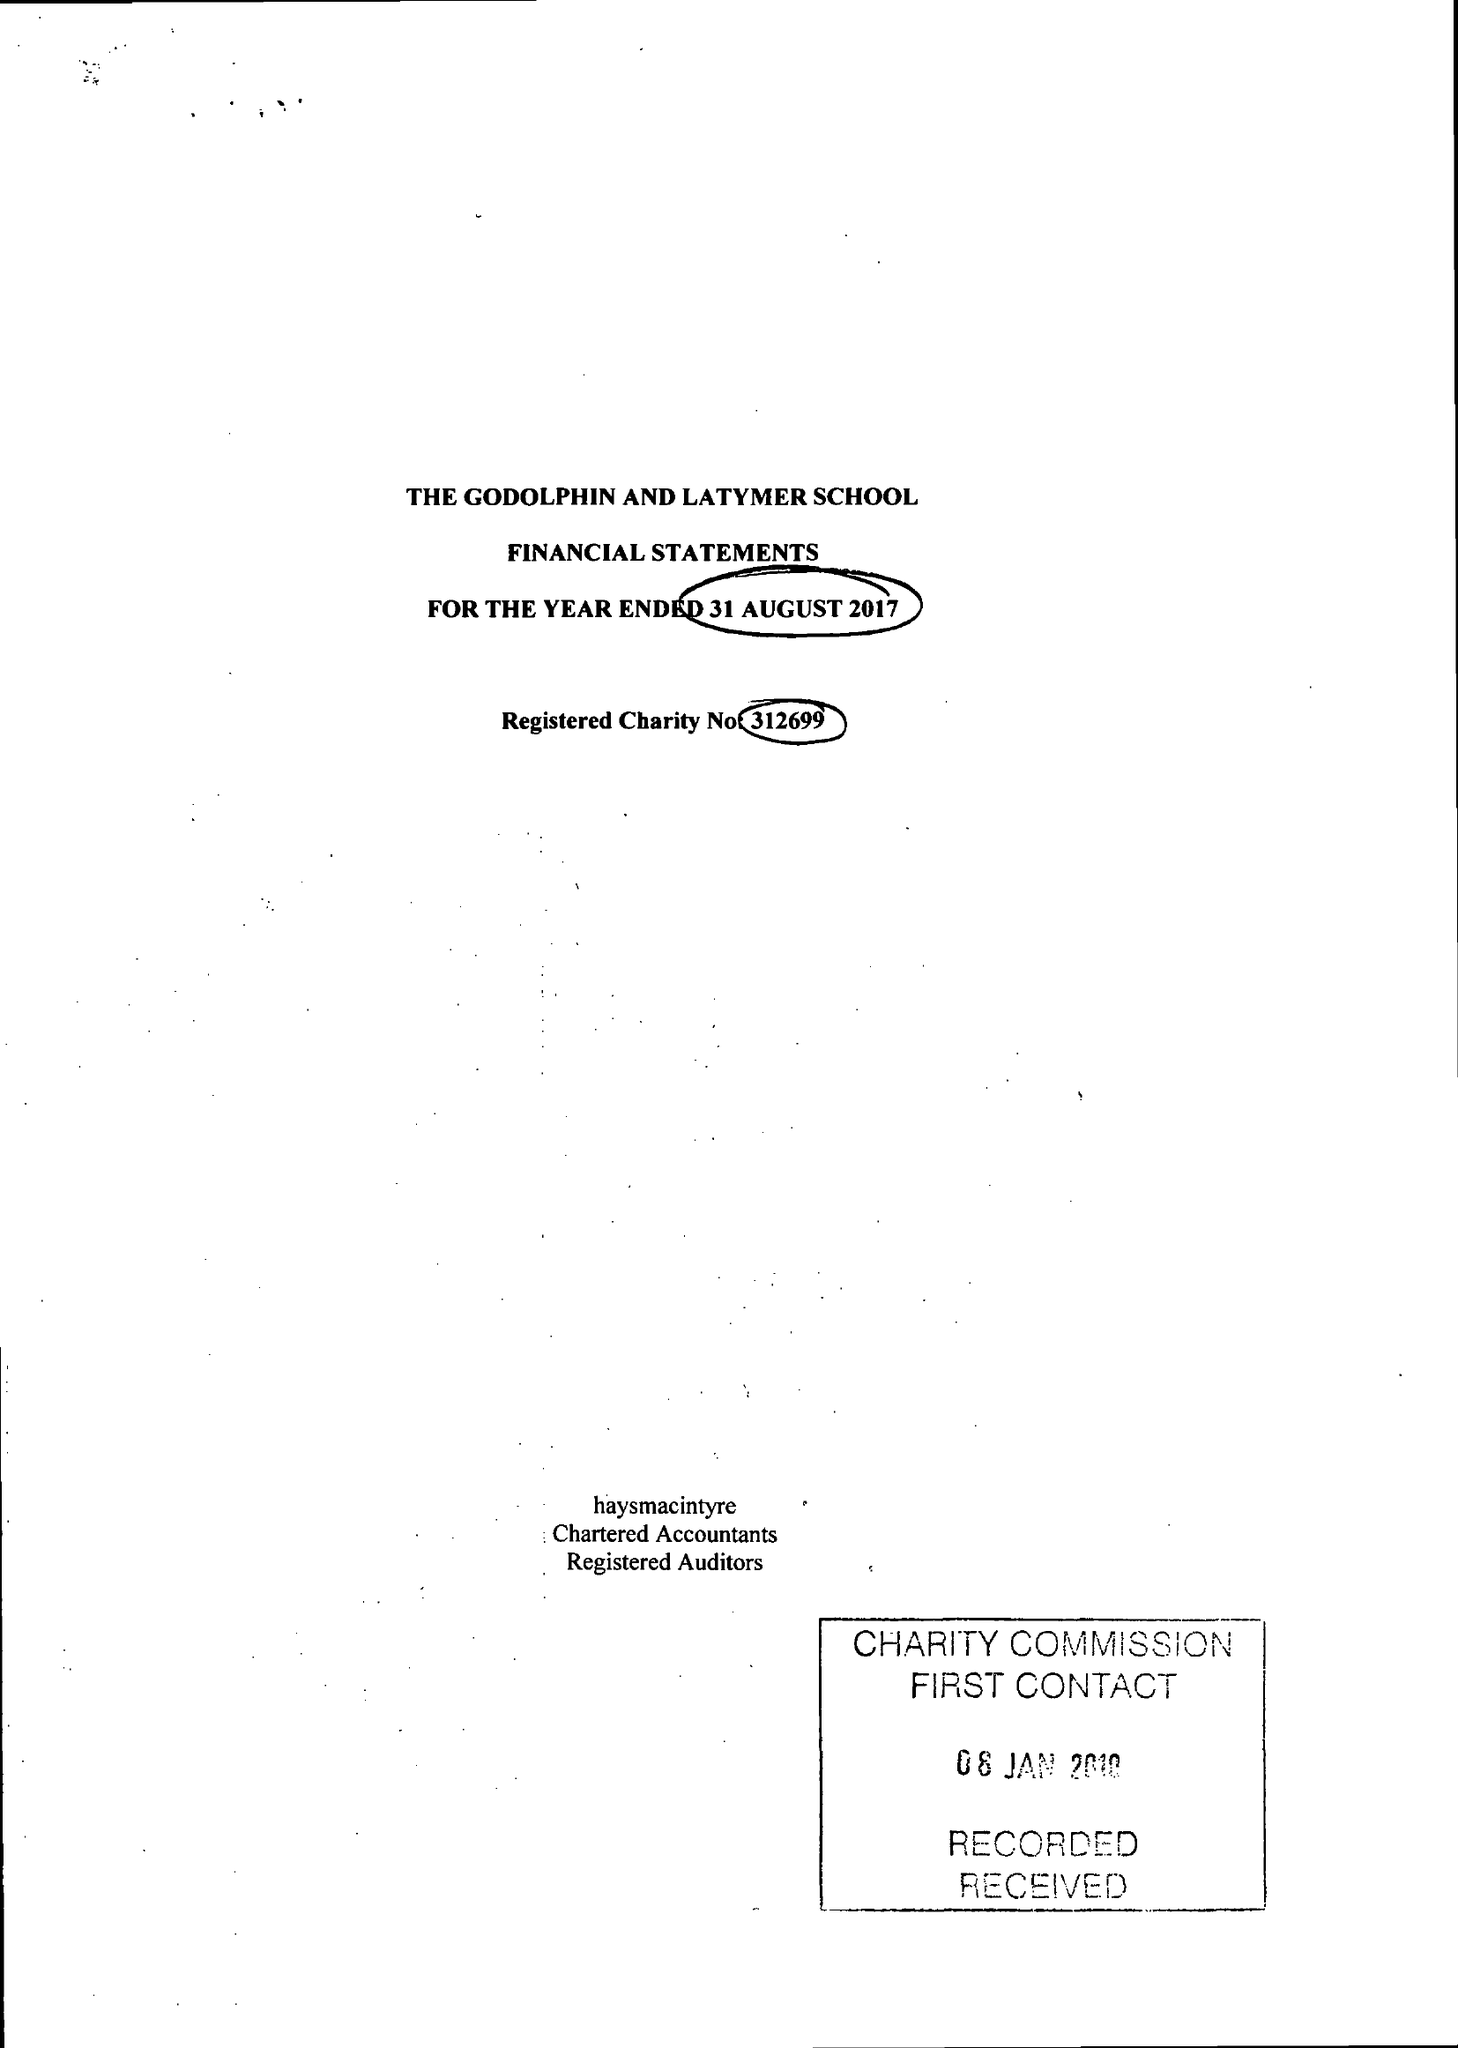What is the value for the charity_number?
Answer the question using a single word or phrase. 312699 